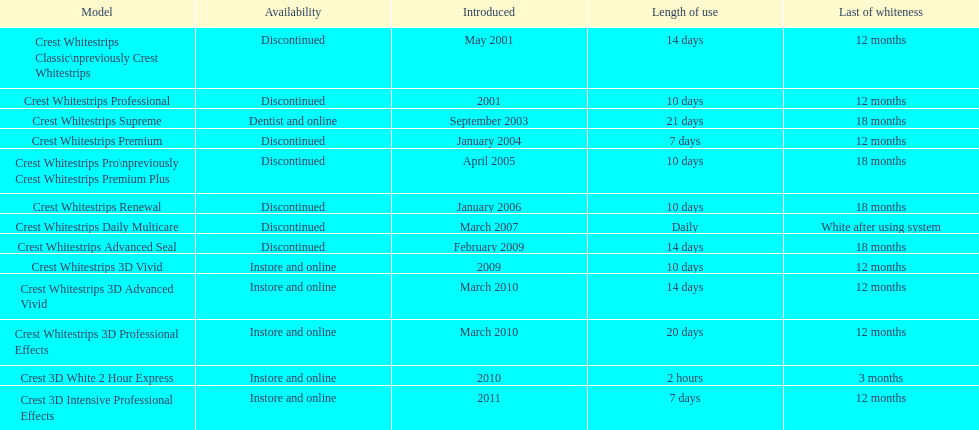What is the number of products that were introduced in 2010? 3. 